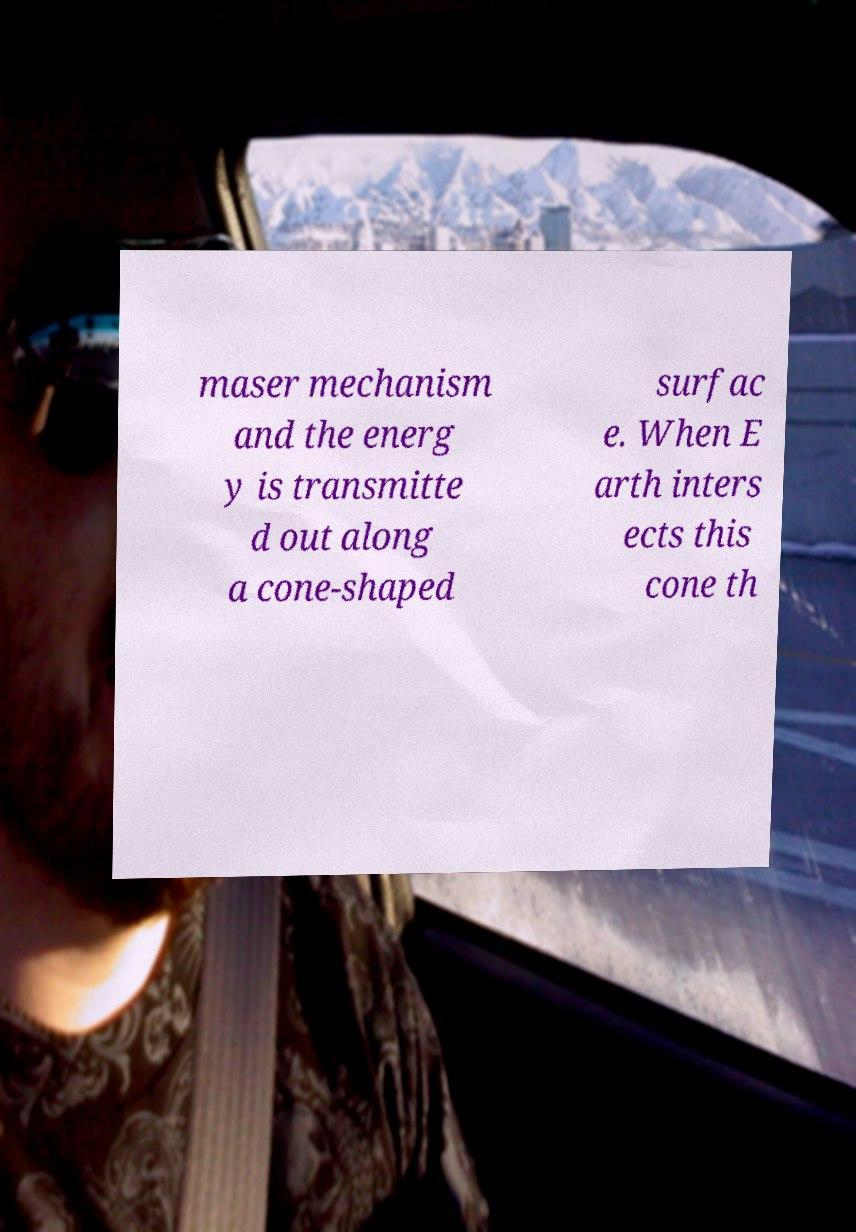For documentation purposes, I need the text within this image transcribed. Could you provide that? maser mechanism and the energ y is transmitte d out along a cone-shaped surfac e. When E arth inters ects this cone th 